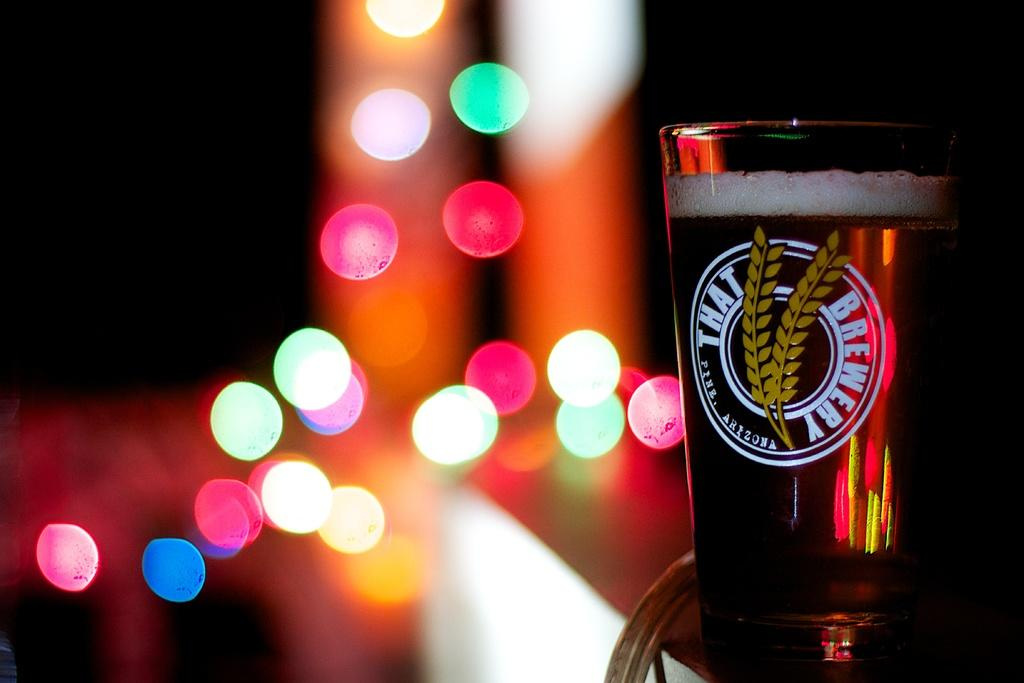Provide a one-sentence caption for the provided image. A beer glass with advertises That Brewery that is filled with beer. 